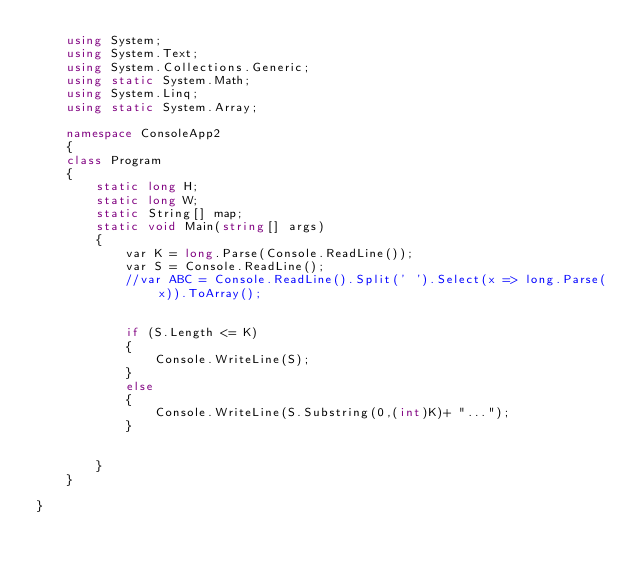<code> <loc_0><loc_0><loc_500><loc_500><_C#_>    using System;
    using System.Text;
    using System.Collections.Generic;
    using static System.Math;
    using System.Linq;
    using static System.Array;
    
    namespace ConsoleApp2
    {
    class Program
    {
        static long H;
        static long W;
        static String[] map;
        static void Main(string[] args)
        {
            var K = long.Parse(Console.ReadLine());
            var S = Console.ReadLine();
            //var ABC = Console.ReadLine().Split(' ').Select(x => long.Parse(x)).ToArray();


            if (S.Length <= K)
            {
                Console.WriteLine(S);
            }
            else
            {
                Console.WriteLine(S.Substring(0,(int)K)+ "...");
            }


        }
    }

}
</code> 